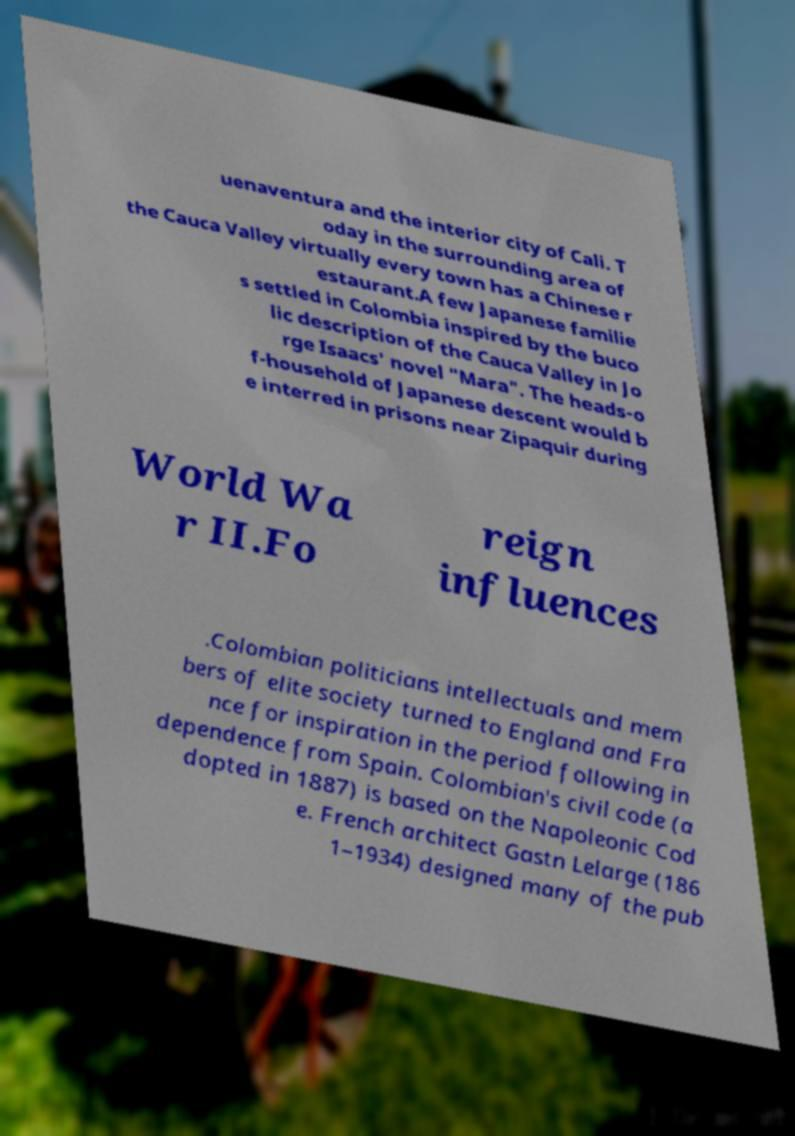There's text embedded in this image that I need extracted. Can you transcribe it verbatim? uenaventura and the interior city of Cali. T oday in the surrounding area of the Cauca Valley virtually every town has a Chinese r estaurant.A few Japanese familie s settled in Colombia inspired by the buco lic description of the Cauca Valley in Jo rge Isaacs' novel "Mara". The heads-o f-household of Japanese descent would b e interred in prisons near Zipaquir during World Wa r II.Fo reign influences .Colombian politicians intellectuals and mem bers of elite society turned to England and Fra nce for inspiration in the period following in dependence from Spain. Colombian's civil code (a dopted in 1887) is based on the Napoleonic Cod e. French architect Gastn Lelarge (186 1–1934) designed many of the pub 